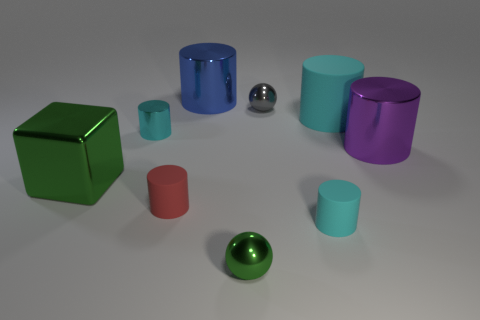Subtract all cyan cylinders. How many were subtracted if there are1cyan cylinders left? 2 Subtract all large cyan cylinders. How many cylinders are left? 5 Subtract all cylinders. How many objects are left? 3 Subtract all red cylinders. How many cylinders are left? 5 Subtract all purple blocks. Subtract all brown cylinders. How many blocks are left? 1 Subtract all red balls. How many red cylinders are left? 1 Subtract all red cylinders. Subtract all small red objects. How many objects are left? 7 Add 1 tiny gray metal balls. How many tiny gray metal balls are left? 2 Add 3 large purple objects. How many large purple objects exist? 4 Subtract 0 yellow cubes. How many objects are left? 9 